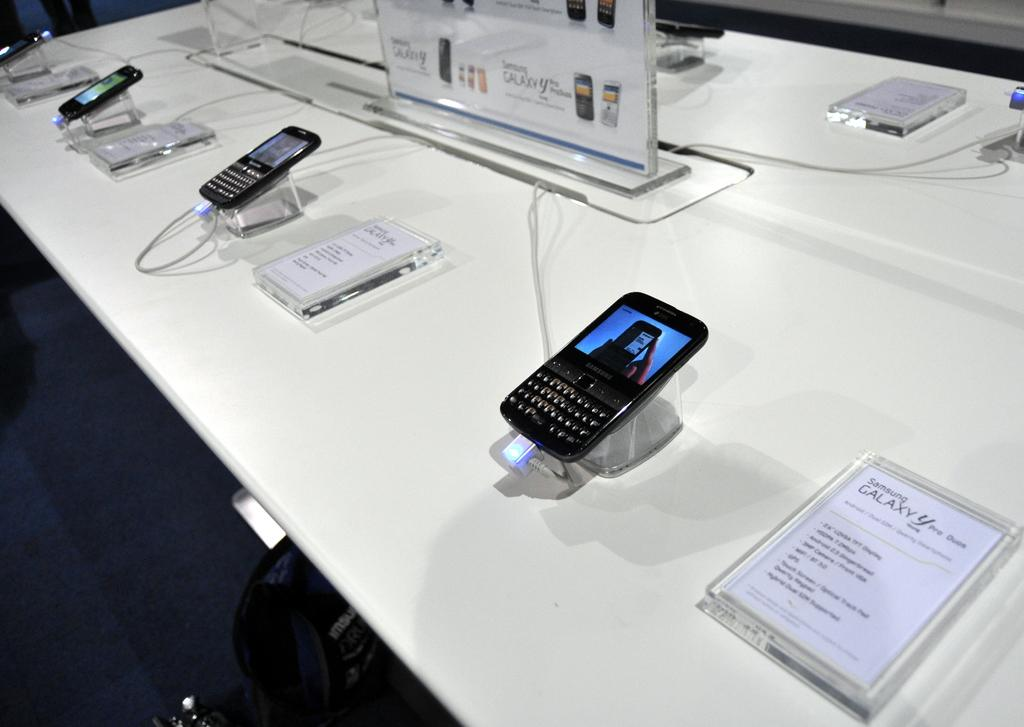<image>
Create a compact narrative representing the image presented. A Samsung Galaxy is displayed next to an information sheet. 